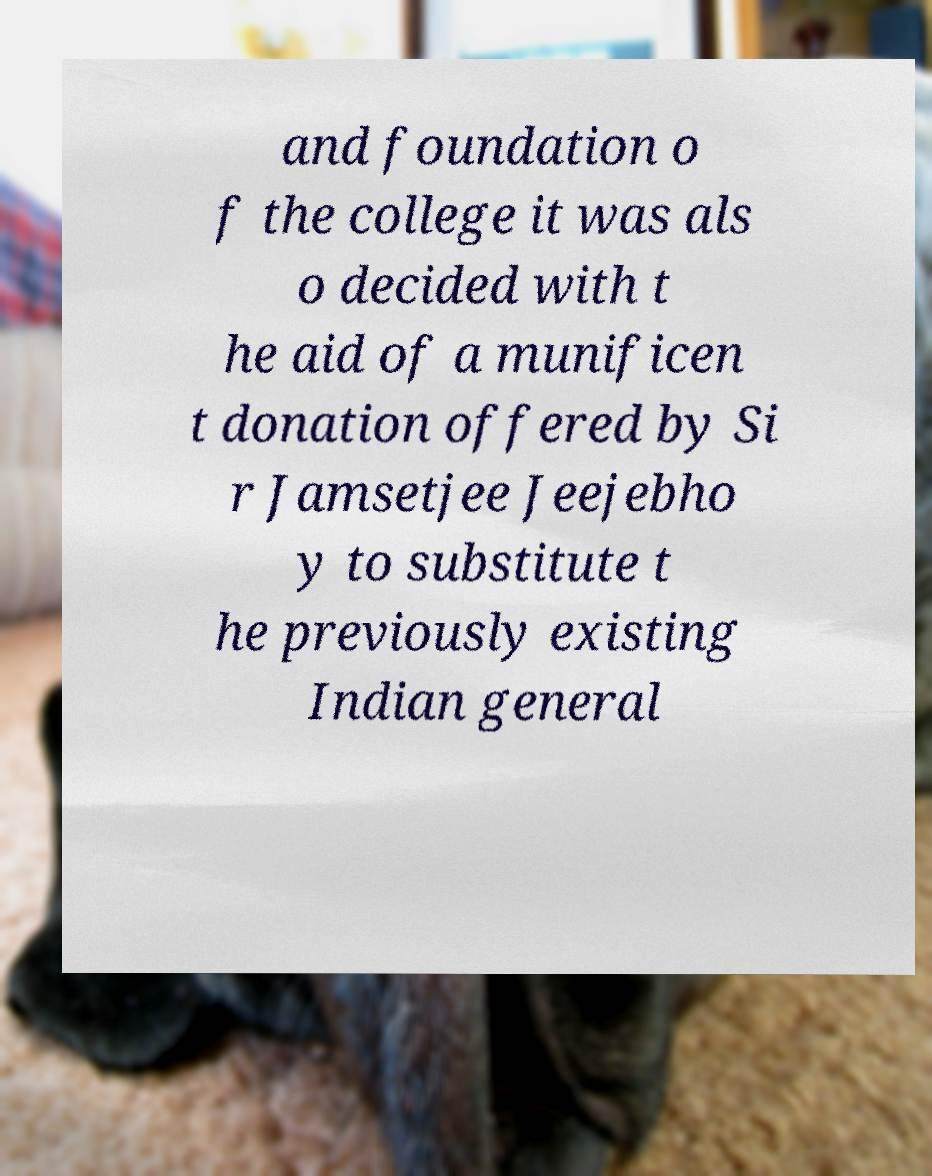Please read and relay the text visible in this image. What does it say? and foundation o f the college it was als o decided with t he aid of a munificen t donation offered by Si r Jamsetjee Jeejebho y to substitute t he previously existing Indian general 